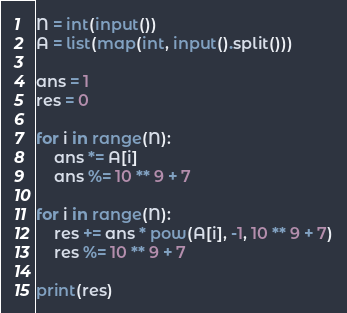Convert code to text. <code><loc_0><loc_0><loc_500><loc_500><_Python_>N = int(input())
A = list(map(int, input().split()))

ans = 1
res = 0

for i in range(N):
    ans *= A[i]
    ans %= 10 ** 9 + 7

for i in range(N):
    res += ans * pow(A[i], -1, 10 ** 9 + 7)
    res %= 10 ** 9 + 7

print(res)</code> 